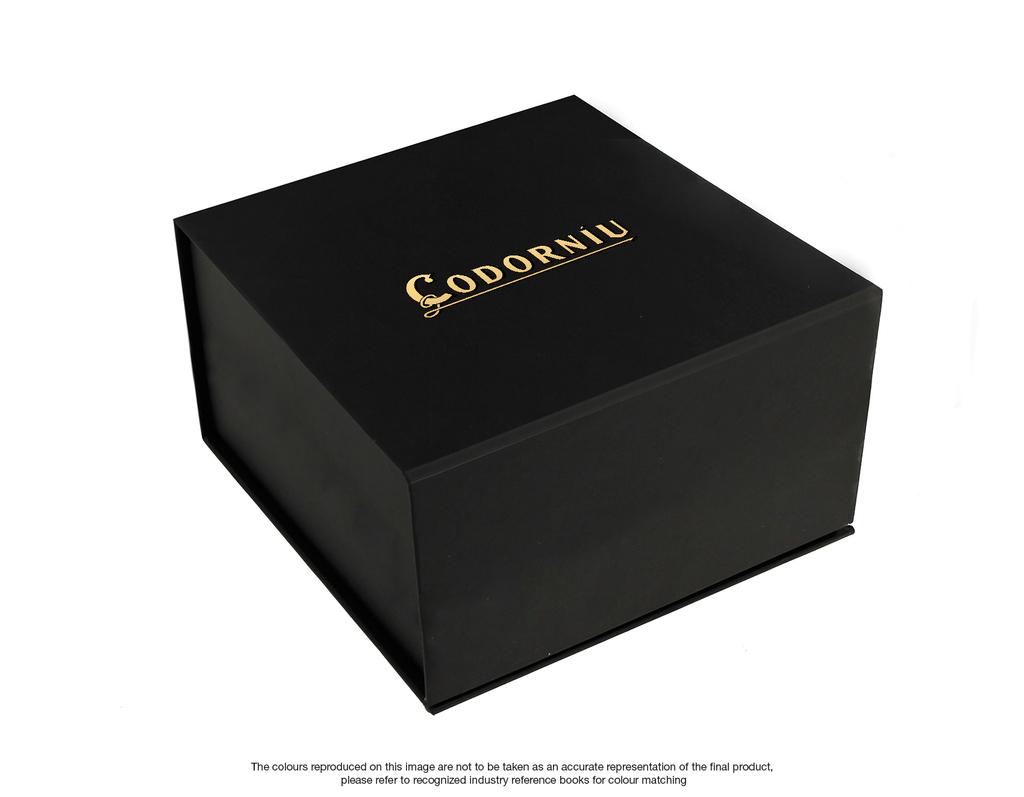What brand is shown on this box?
Ensure brevity in your answer.  Codorniu. 